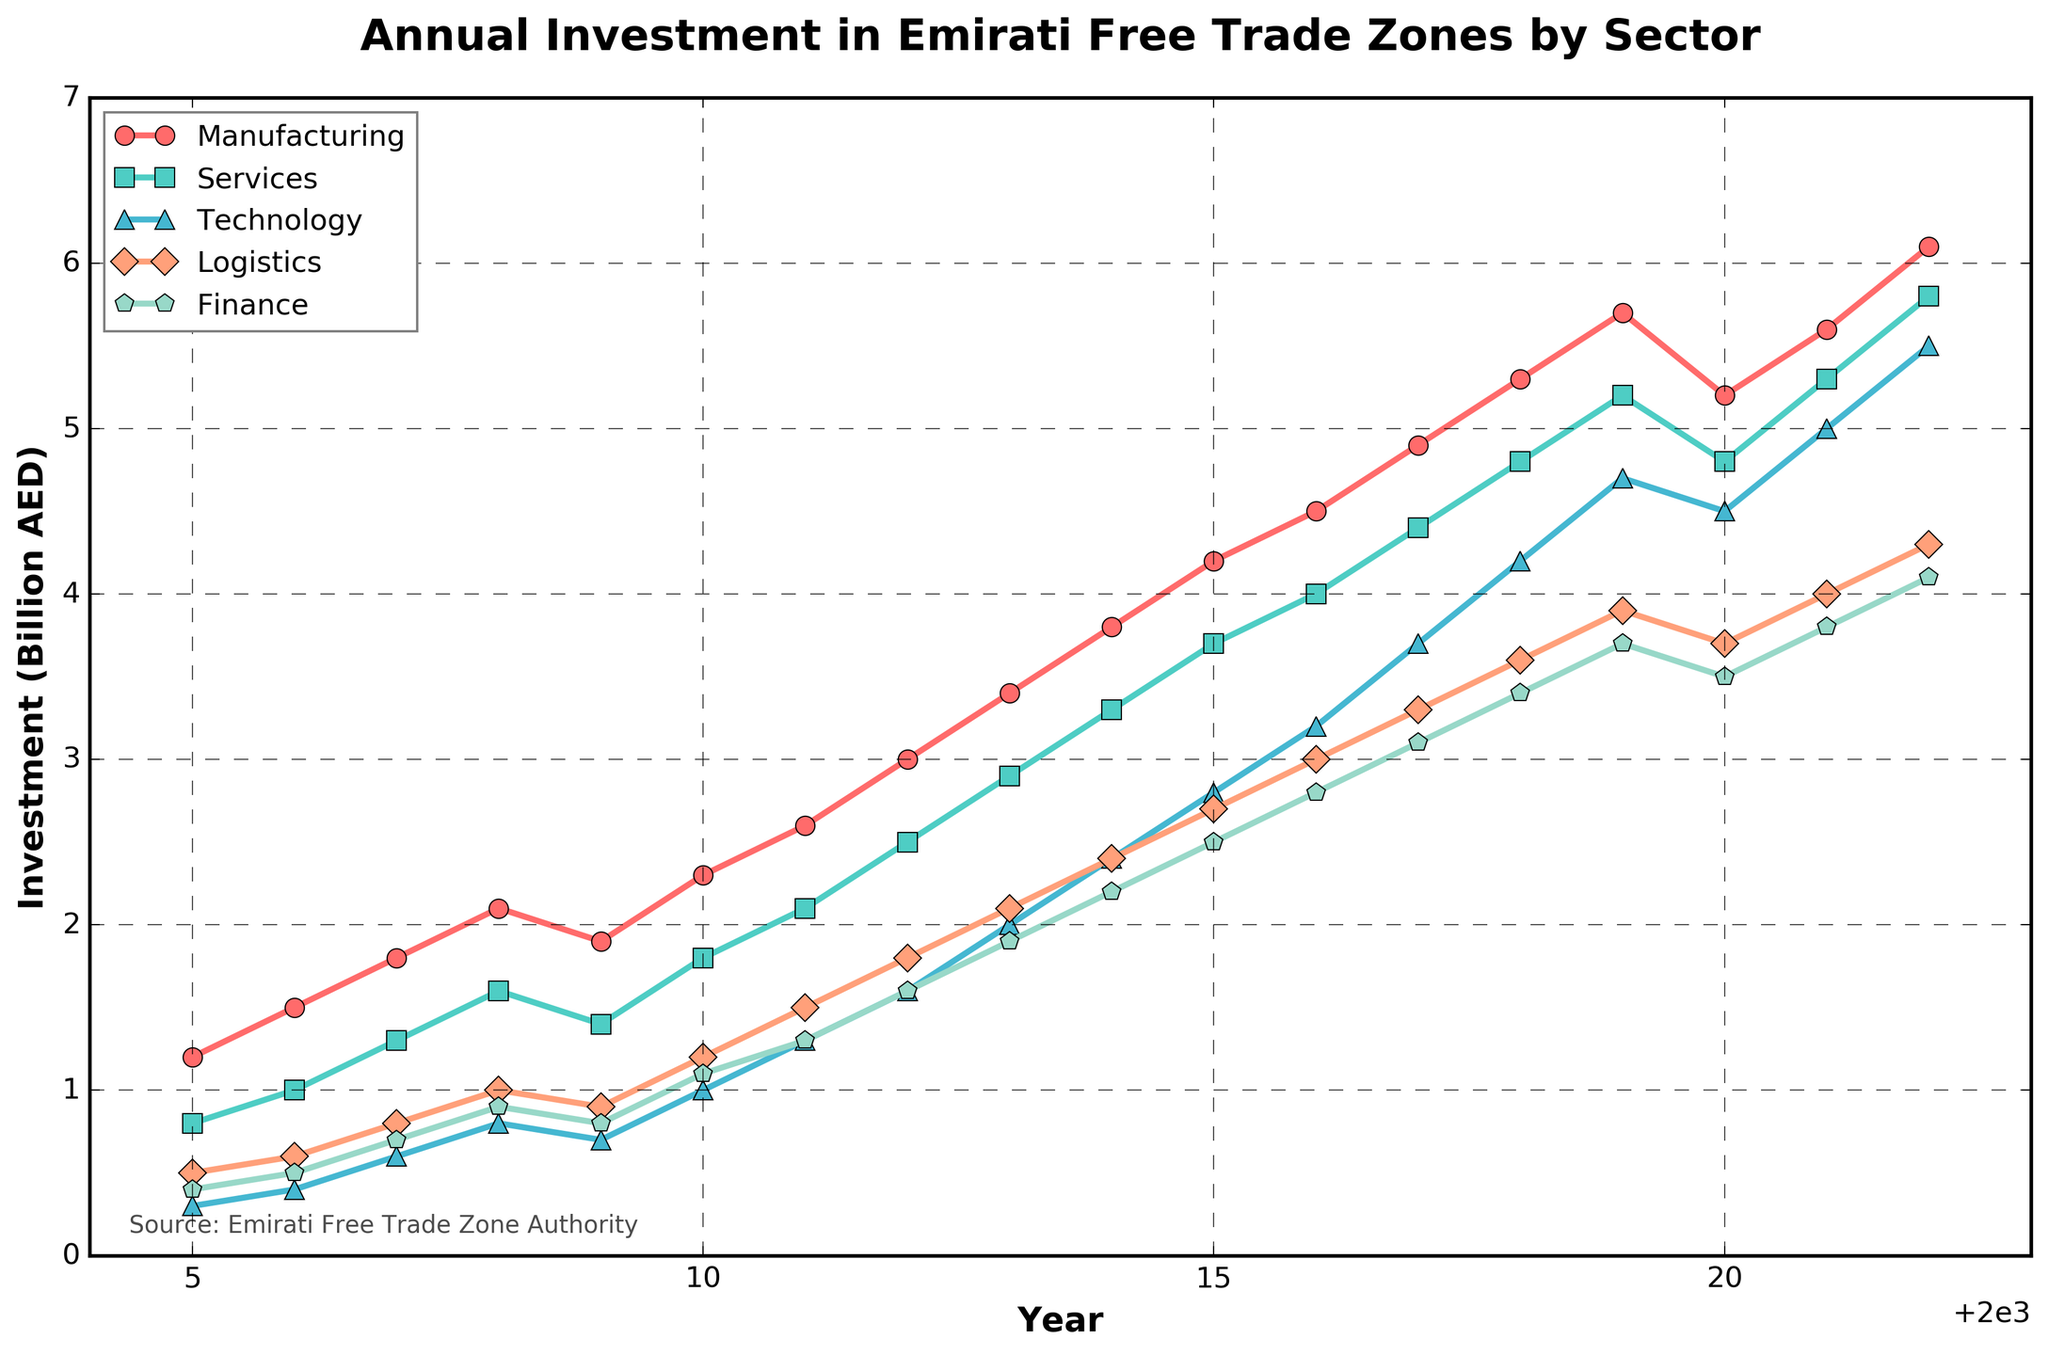What was the peak investment value in the Manufacturing sector? By examining the Manufacturing sector line, the highest point is reached in 2022 with a value of 6.1 billion AED.
Answer: 6.1 billion AED Which sector experienced the largest drop in investment between 2019 and 2020? By comparing the lines for the sectors between 2019 and 2020, Manufacturing saw a decrease from 5.7 to 5.2 billion AED, which is the largest drop.
Answer: Manufacturing What is the average investment in the Technology sector from 2005 to 2022? First, sum the investment values for each year (0.3 + 0.4 + 0.6 + 0.8 + 0.7 + 1.0 + 1.3 + 1.6 + 2.0 + 2.4 + 2.8 + 3.2 + 3.7 + 4.2 + 4.7 + 4.5 + 5.0 + 5.5 = 45.7). There are 18 years, so 45.7 / 18 = 2.54 billion AED.
Answer: 2.54 billion AED Which sector surpassed a 4.0 billion AED investment the earliest? By looking at the points where each line first crosses the 4.0 billion AED mark, Manufacturing is the first sector to do so in 2015.
Answer: Manufacturing How did the investment in Logistics compare to Finance in 2014? In 2014, the Logistics investment value is 2.4 billion AED and Finance is 2.2 billion AED. Logistics investment is slightly higher than Finance.
Answer: Logistics higher than Finance What's the sum of investments for all sectors in 2022? The investments for 2022 are: Manufacturing (6.1), Services (5.8), Technology (5.5), Logistics (4.3), and Finance (4.1). Sum these values: 6.1 + 5.8 + 5.5 + 4.3 + 4.1 = 25.8 billion AED.
Answer: 25.8 billion AED In what year did the Technology sector investment first exceed 3 billion AED? The Technology sector investment exceeds 3 billion AED for the first time in 2016, with an investment of 3.2 billion AED.
Answer: 2016 How many sectors had an investment of over 5 billion AED in 2021? In 2021, the investments are: Manufacturing (5.6), Services (5.3), Technology (5.0), Logistics (4.0), and Finance (3.8). Three sectors (Manufacturing, Services, Technology) had investments over 5 billion AED.
Answer: 3 